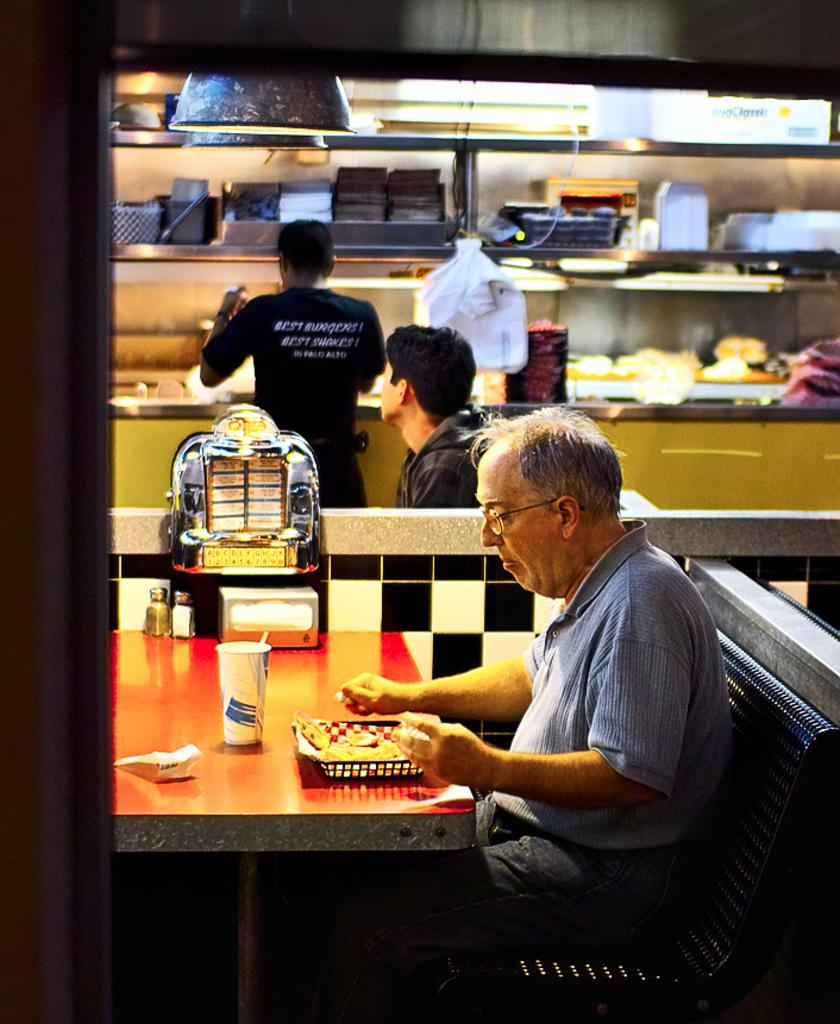What piece of furniture is present in the image? There is a table in the image. What is happening at the table? A man is having his food at the table. What else can be seen on the table? There are objects on the table. Can you describe the background of the image? There are two people in the background. What else can be seen in the image besides the table and people? There is a shelf with some objects in the image. What type of disease is being treated by the man at the table? There is no indication of a disease or medical treatment in the image; it simply shows a man having his food at a table. 